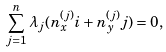Convert formula to latex. <formula><loc_0><loc_0><loc_500><loc_500>\sum _ { j = 1 } ^ { n } \lambda _ { j } ( n ^ { ( j ) } _ { x } i + n ^ { ( j ) } _ { y } j ) = 0 ,</formula> 